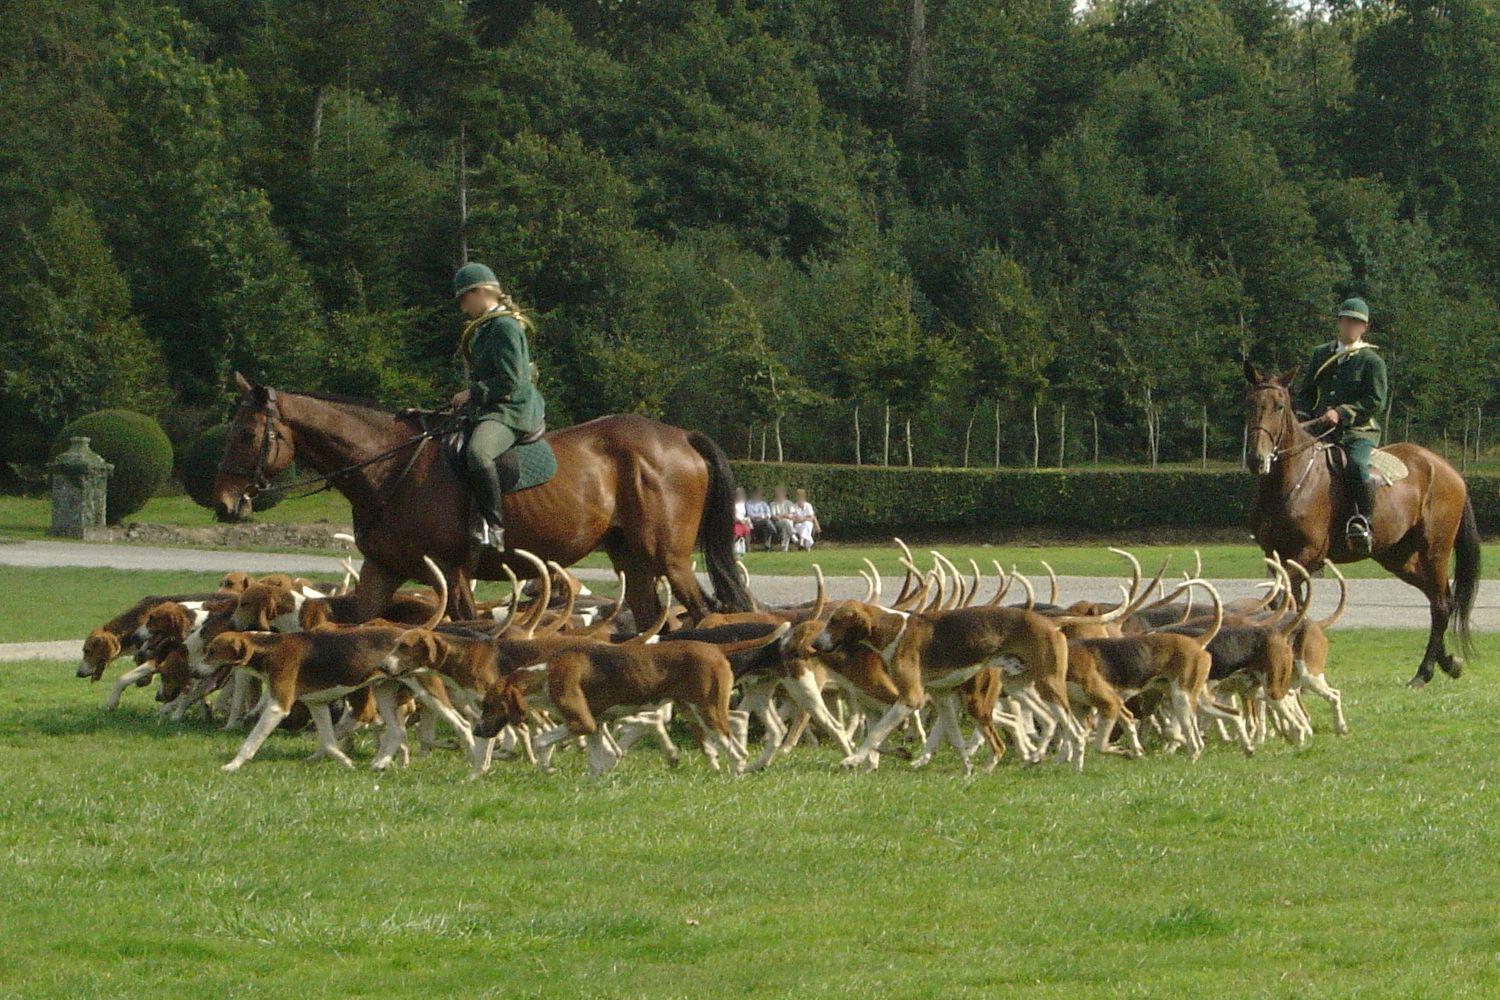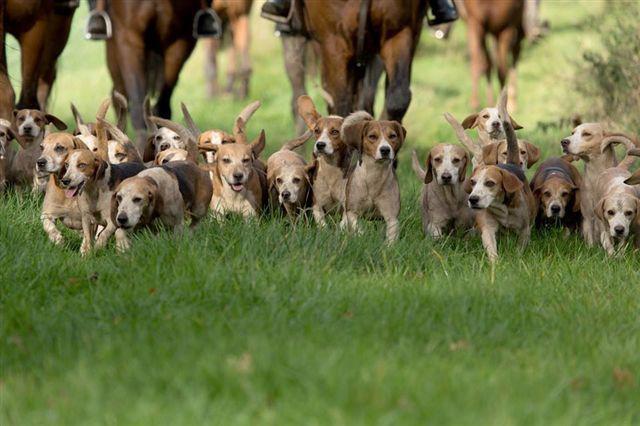The first image is the image on the left, the second image is the image on the right. For the images displayed, is the sentence "There is at least one person in a red jacket riding a horse in one of the images." factually correct? Answer yes or no. No. The first image is the image on the left, the second image is the image on the right. Considering the images on both sides, is "An image shows a man in white pants astride a horse in the foreground, and includes someone in a red jacket somewhere in the scene." valid? Answer yes or no. No. 